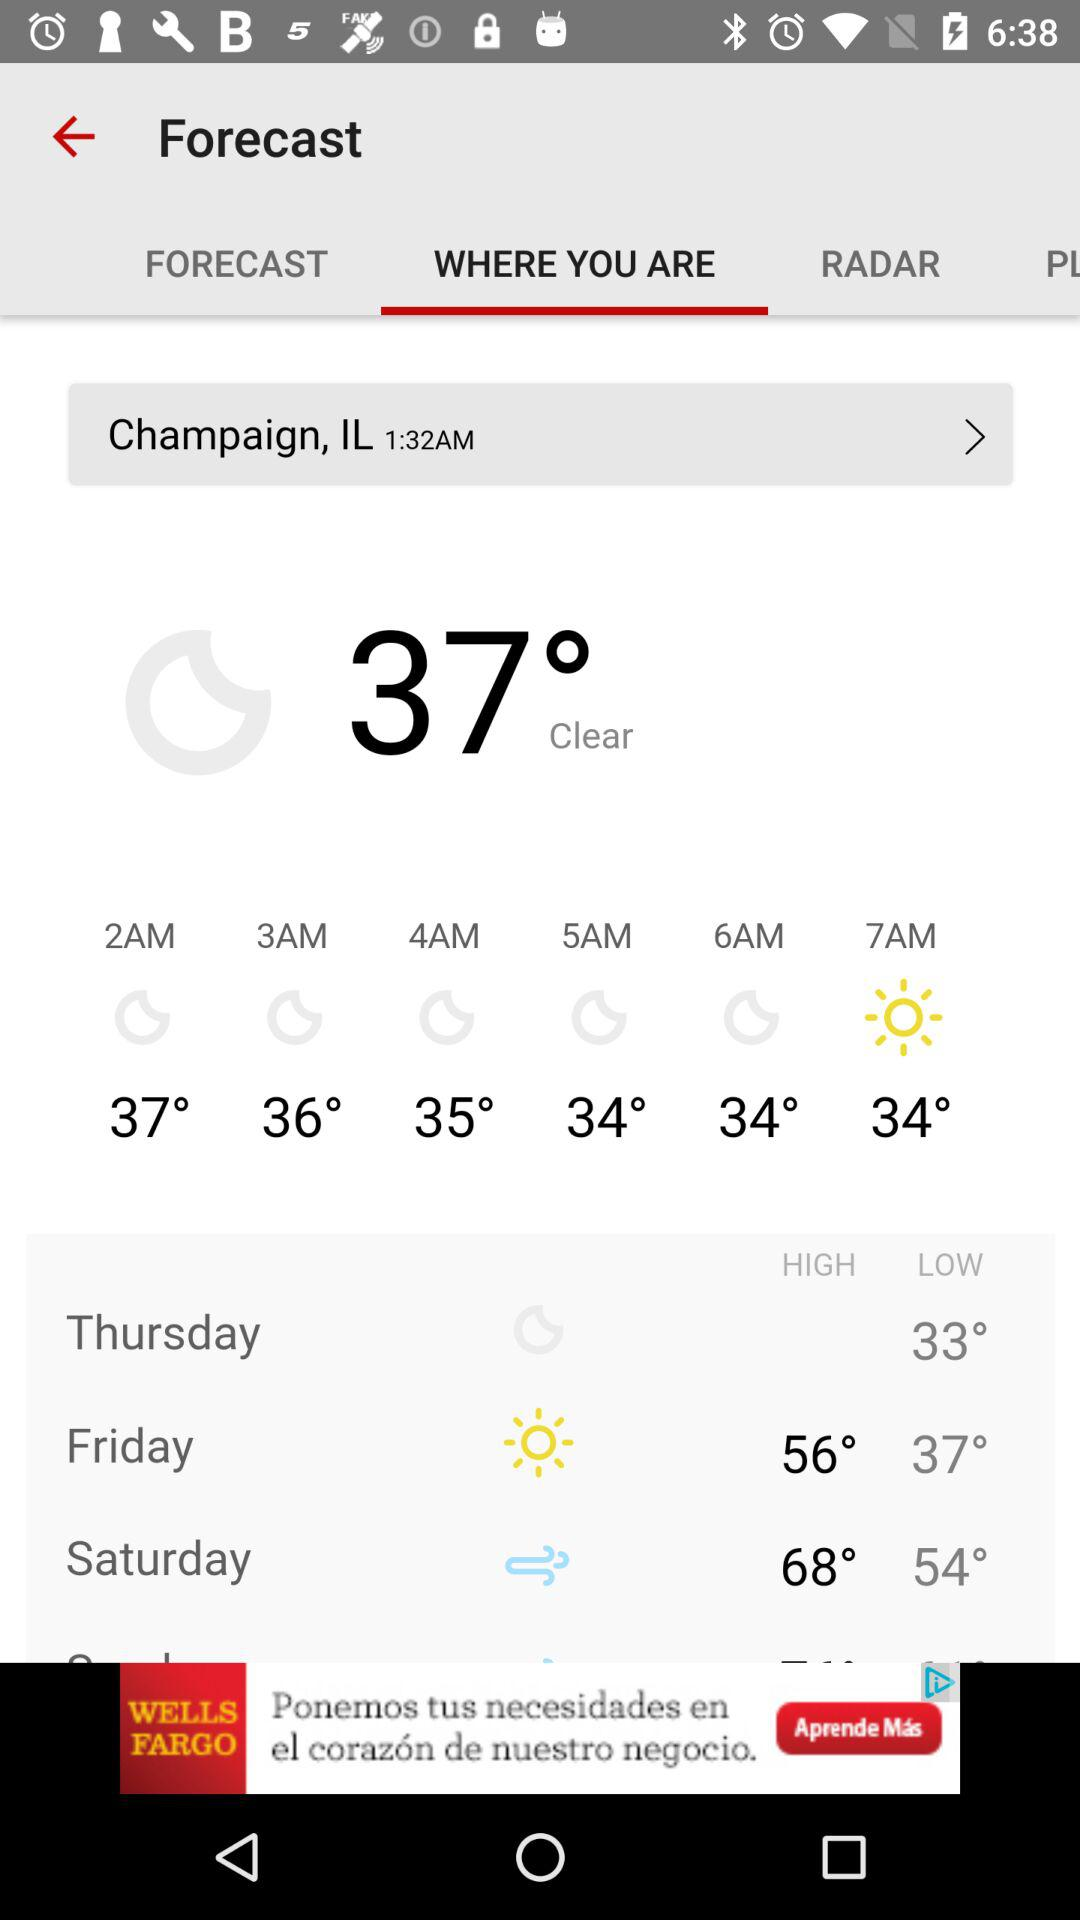How many degrees is the high temperature on Saturday?
Answer the question using a single word or phrase. 68° 